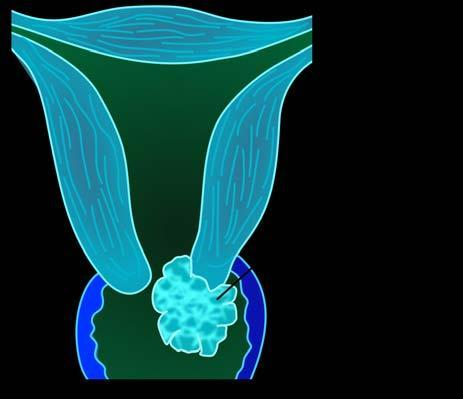what shows replacement of the cervix by irregular greywhite friable growth extending into cervical canal as well as distally into attached vaginal cuff?
Answer the question using a single word or phrase. Gross photograph on right 